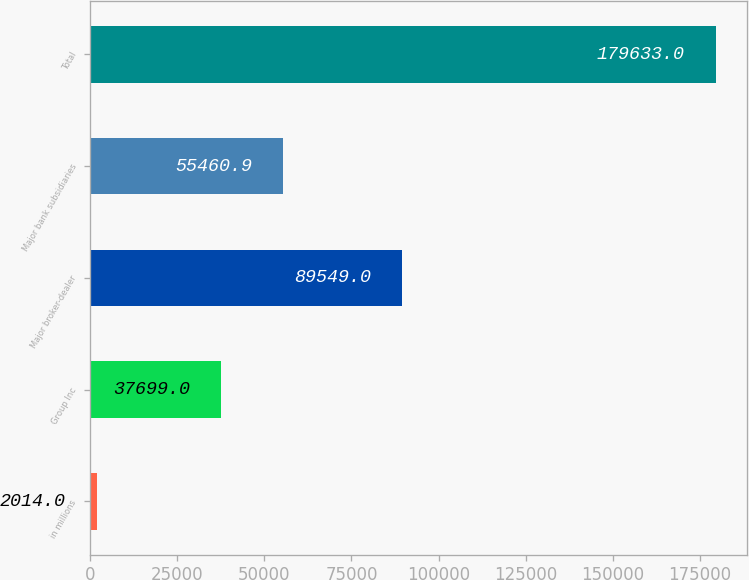Convert chart to OTSL. <chart><loc_0><loc_0><loc_500><loc_500><bar_chart><fcel>in millions<fcel>Group Inc<fcel>Major broker-dealer<fcel>Major bank subsidiaries<fcel>Total<nl><fcel>2014<fcel>37699<fcel>89549<fcel>55460.9<fcel>179633<nl></chart> 